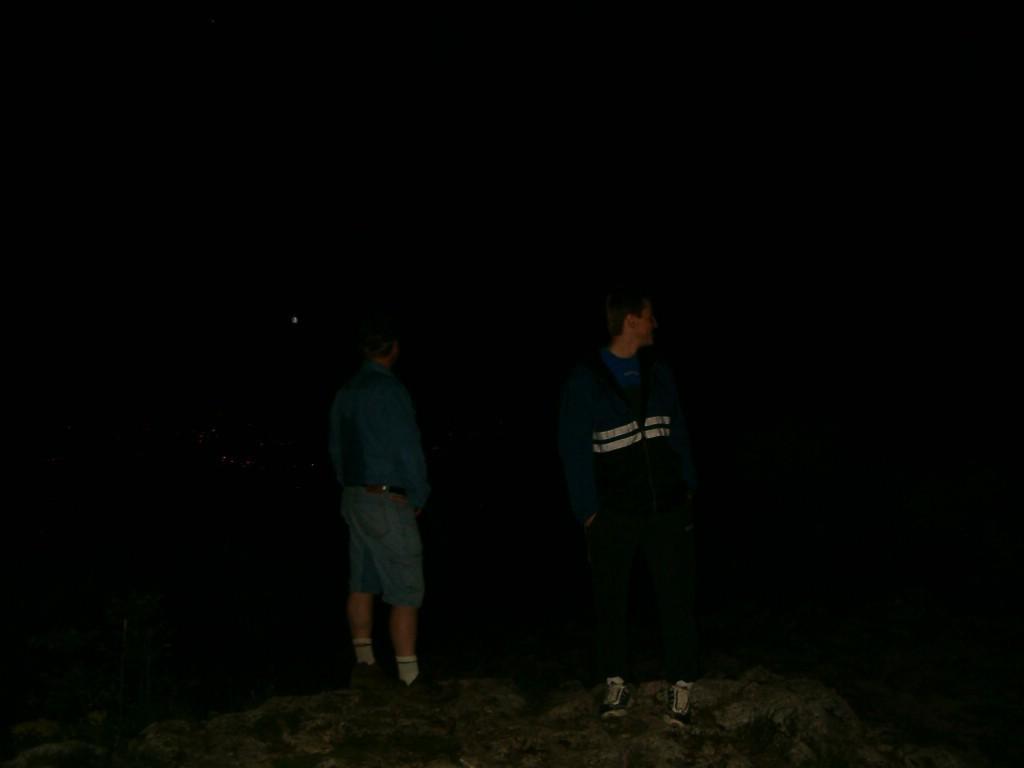In one or two sentences, can you explain what this image depicts? In this image we can see two persons standing on the rock in the dark. 